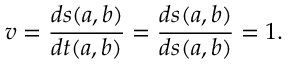<formula> <loc_0><loc_0><loc_500><loc_500>v = \frac { d s ( a , b ) } { d t ( a , b ) } = \frac { d s ( a , b ) } { d s ( a , b ) } = 1 .</formula> 